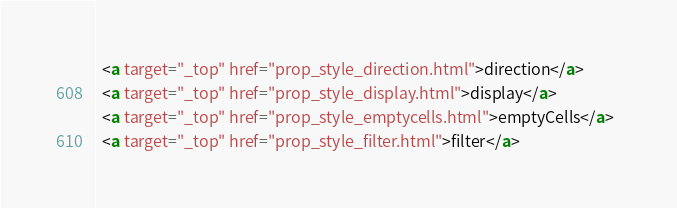Convert code to text. <code><loc_0><loc_0><loc_500><loc_500><_HTML_>  <a target="_top" href="prop_style_direction.html">direction</a>  
  <a target="_top" href="prop_style_display.html">display</a>  
  <a target="_top" href="prop_style_emptycells.html">emptyCells</a>  
  <a target="_top" href="prop_style_filter.html">filter</a>  </code> 